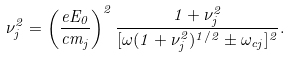Convert formula to latex. <formula><loc_0><loc_0><loc_500><loc_500>\nu ^ { 2 } _ { j } = \left ( \frac { e E _ { 0 } } { c m _ { j } } \right ) ^ { 2 } \frac { 1 + \nu ^ { 2 } _ { j } } { [ \omega ( 1 + \nu ^ { 2 } _ { j } ) ^ { 1 / 2 } \pm \omega _ { c j } ] ^ { 2 } } .</formula> 